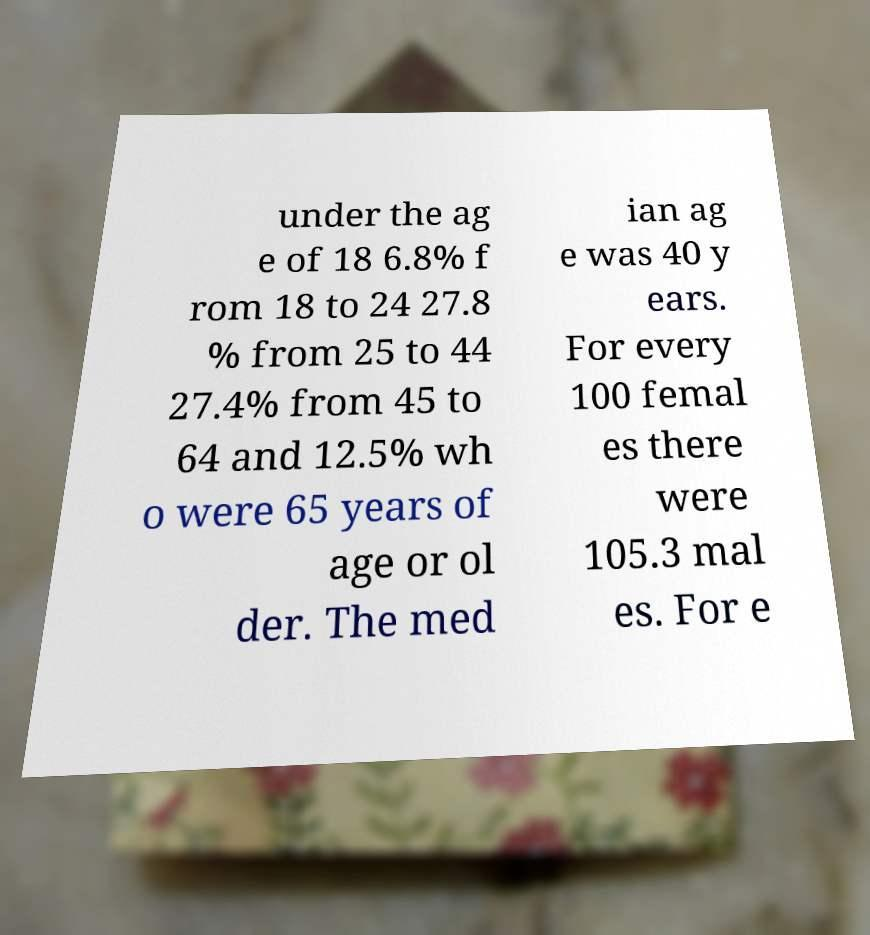For documentation purposes, I need the text within this image transcribed. Could you provide that? under the ag e of 18 6.8% f rom 18 to 24 27.8 % from 25 to 44 27.4% from 45 to 64 and 12.5% wh o were 65 years of age or ol der. The med ian ag e was 40 y ears. For every 100 femal es there were 105.3 mal es. For e 